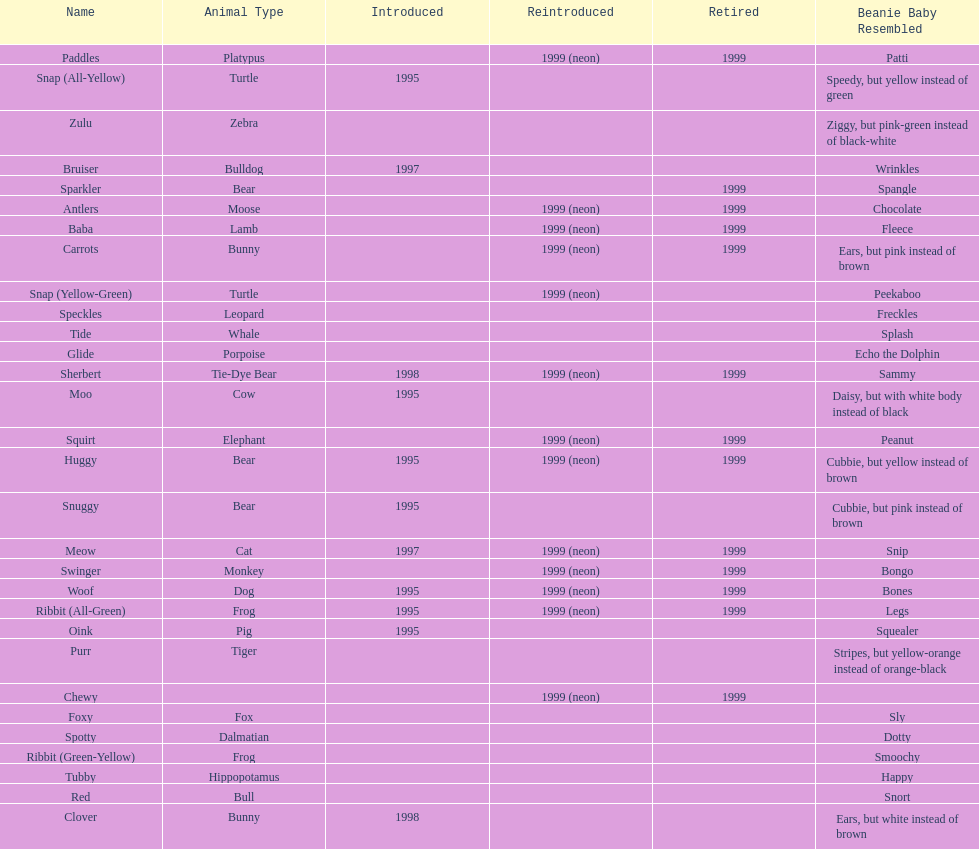Which animal type has the most pillow pals? Bear. 